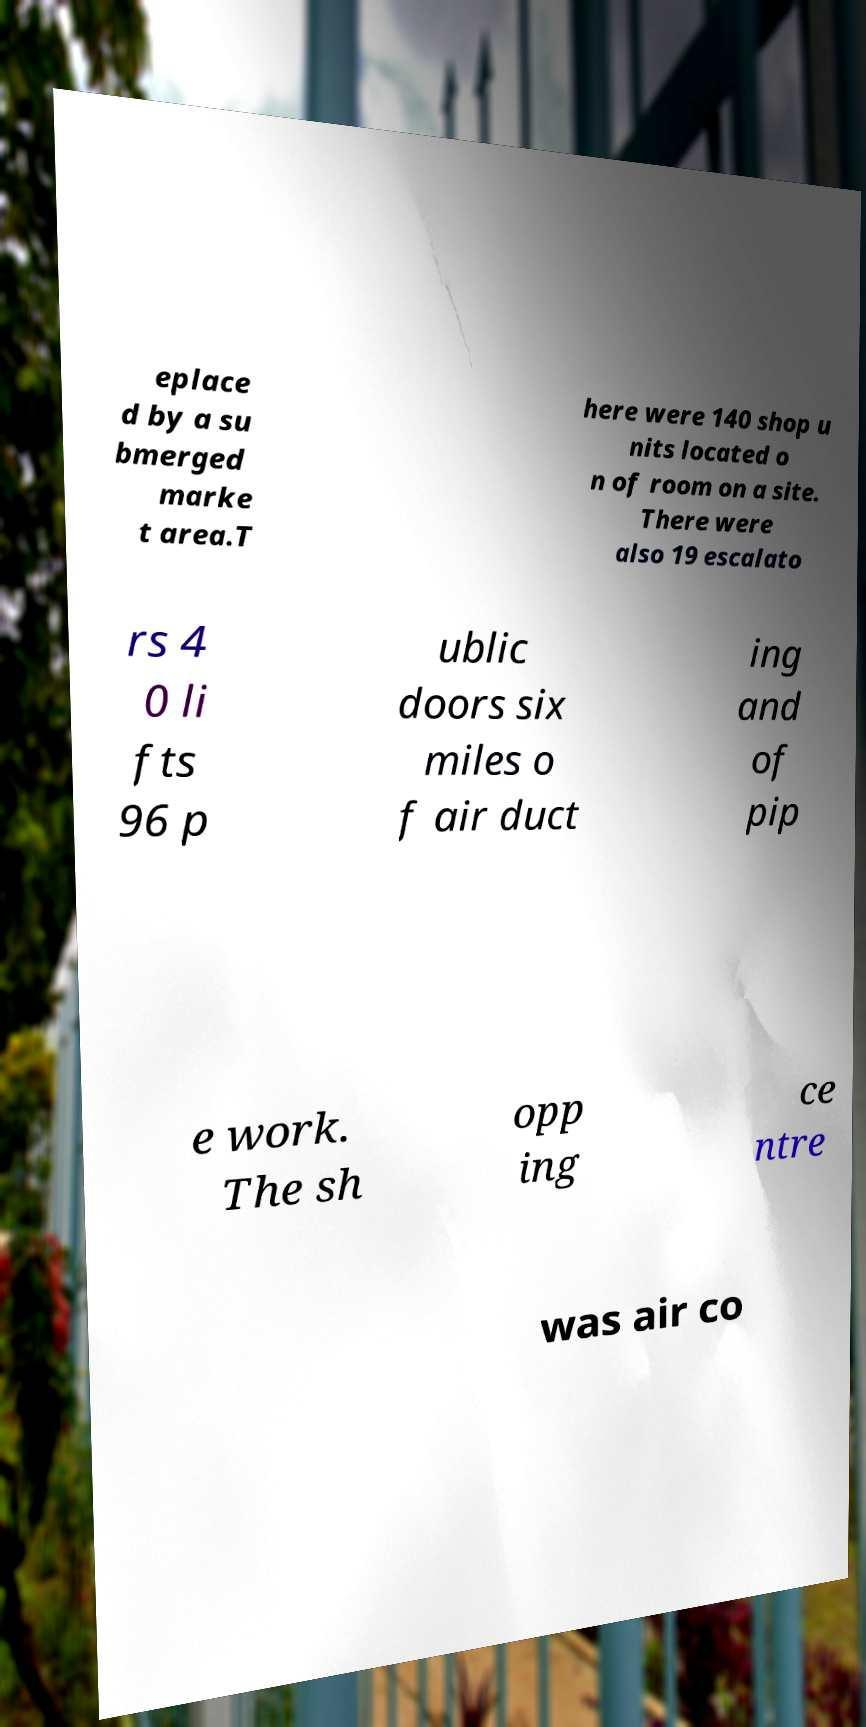For documentation purposes, I need the text within this image transcribed. Could you provide that? eplace d by a su bmerged marke t area.T here were 140 shop u nits located o n of room on a site. There were also 19 escalato rs 4 0 li fts 96 p ublic doors six miles o f air duct ing and of pip e work. The sh opp ing ce ntre was air co 